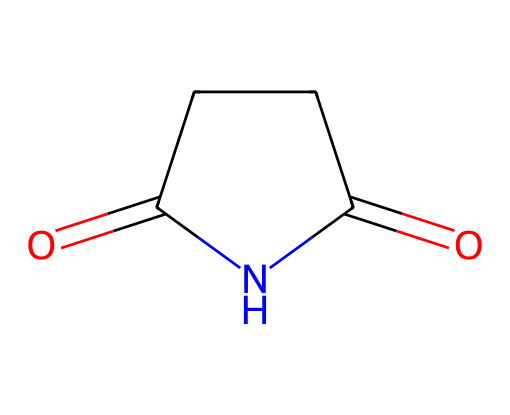What is the name of this chemical? The SMILES representation O=C1CCC(=O)N1 corresponds to the molecular structure of succinimide, which is a cyclic imide compound.
Answer: succinimide How many carbon atoms are in this structure? Analyzing the structure, there are four carbon atoms indicated in the SMILES as each 'C' represents a carbon atom.
Answer: 4 How many nitrogen atoms are present in this molecule? The SMILES includes one 'N', indicating that there is one nitrogen atom in the molecule's structure.
Answer: 1 What type of functional groups does this compound contain? The structure shows both ketone (C=O) and imide (cyclic structure with nitrogen) functional groups, typical for succinimide.
Answer: ketone and imide Why is succinimide used in flame retardants? Succinimide’s cyclic imide structure provides thermal stability and limits flammability when added to materials, helping them resist combustion.
Answer: thermal stability What does the cyclic structure of succinimide imply about its chemical properties? The cyclic structure contributes to the molecule’s stability, making it more resistant to hydrolysis and increasing its durability in various applications.
Answer: stability What can you infer about succinimide's solubility in water based on its structure? Given the presence of a polar amide bond in the cyclic structure, succinimide is likely to have moderate solubility in water due to hydrogen bonding capabilities.
Answer: moderate solubility 